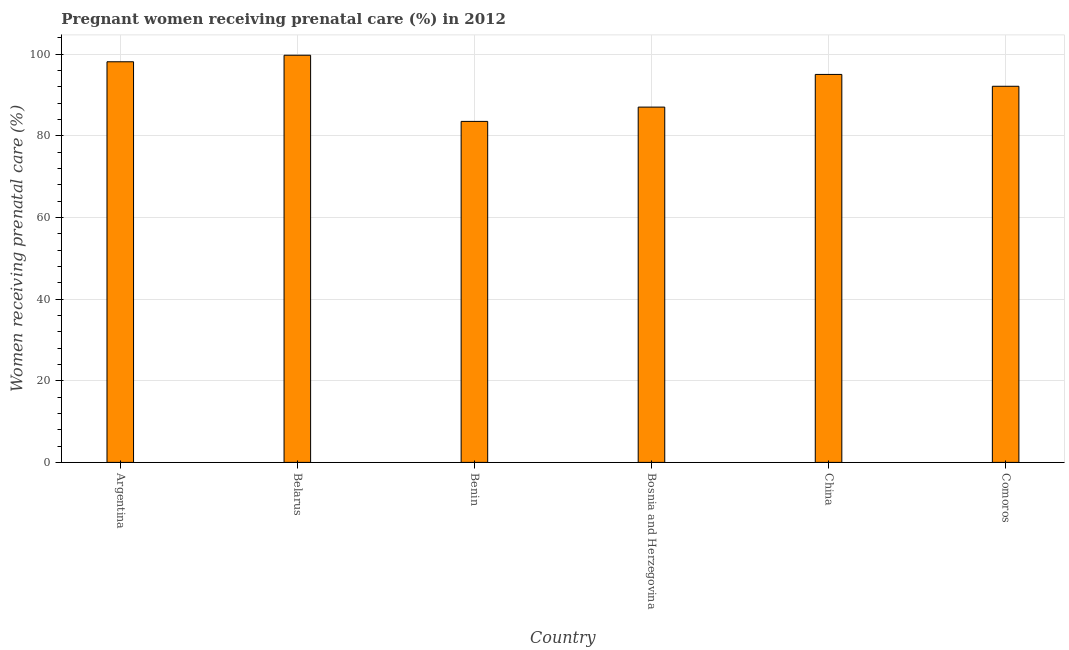What is the title of the graph?
Offer a very short reply. Pregnant women receiving prenatal care (%) in 2012. What is the label or title of the X-axis?
Your response must be concise. Country. What is the label or title of the Y-axis?
Provide a succinct answer. Women receiving prenatal care (%). What is the percentage of pregnant women receiving prenatal care in China?
Make the answer very short. 95. Across all countries, what is the maximum percentage of pregnant women receiving prenatal care?
Offer a very short reply. 99.7. Across all countries, what is the minimum percentage of pregnant women receiving prenatal care?
Your answer should be compact. 83.5. In which country was the percentage of pregnant women receiving prenatal care maximum?
Offer a very short reply. Belarus. In which country was the percentage of pregnant women receiving prenatal care minimum?
Your answer should be compact. Benin. What is the sum of the percentage of pregnant women receiving prenatal care?
Offer a very short reply. 555.4. What is the average percentage of pregnant women receiving prenatal care per country?
Give a very brief answer. 92.57. What is the median percentage of pregnant women receiving prenatal care?
Make the answer very short. 93.55. What is the ratio of the percentage of pregnant women receiving prenatal care in Belarus to that in Bosnia and Herzegovina?
Ensure brevity in your answer.  1.15. Is the percentage of pregnant women receiving prenatal care in Argentina less than that in China?
Provide a short and direct response. No. Is the sum of the percentage of pregnant women receiving prenatal care in Bosnia and Herzegovina and Comoros greater than the maximum percentage of pregnant women receiving prenatal care across all countries?
Give a very brief answer. Yes. What is the difference between the highest and the lowest percentage of pregnant women receiving prenatal care?
Give a very brief answer. 16.2. In how many countries, is the percentage of pregnant women receiving prenatal care greater than the average percentage of pregnant women receiving prenatal care taken over all countries?
Make the answer very short. 3. What is the difference between two consecutive major ticks on the Y-axis?
Offer a very short reply. 20. What is the Women receiving prenatal care (%) of Argentina?
Give a very brief answer. 98.1. What is the Women receiving prenatal care (%) in Belarus?
Make the answer very short. 99.7. What is the Women receiving prenatal care (%) in Benin?
Your answer should be very brief. 83.5. What is the Women receiving prenatal care (%) of Comoros?
Give a very brief answer. 92.1. What is the difference between the Women receiving prenatal care (%) in Argentina and Bosnia and Herzegovina?
Make the answer very short. 11.1. What is the difference between the Women receiving prenatal care (%) in Belarus and Bosnia and Herzegovina?
Offer a very short reply. 12.7. What is the difference between the Women receiving prenatal care (%) in Belarus and China?
Make the answer very short. 4.7. What is the difference between the Women receiving prenatal care (%) in Benin and China?
Offer a very short reply. -11.5. What is the difference between the Women receiving prenatal care (%) in Benin and Comoros?
Provide a short and direct response. -8.6. What is the difference between the Women receiving prenatal care (%) in Bosnia and Herzegovina and China?
Provide a succinct answer. -8. What is the difference between the Women receiving prenatal care (%) in China and Comoros?
Offer a terse response. 2.9. What is the ratio of the Women receiving prenatal care (%) in Argentina to that in Benin?
Ensure brevity in your answer.  1.18. What is the ratio of the Women receiving prenatal care (%) in Argentina to that in Bosnia and Herzegovina?
Keep it short and to the point. 1.13. What is the ratio of the Women receiving prenatal care (%) in Argentina to that in China?
Offer a terse response. 1.03. What is the ratio of the Women receiving prenatal care (%) in Argentina to that in Comoros?
Give a very brief answer. 1.06. What is the ratio of the Women receiving prenatal care (%) in Belarus to that in Benin?
Provide a succinct answer. 1.19. What is the ratio of the Women receiving prenatal care (%) in Belarus to that in Bosnia and Herzegovina?
Your answer should be compact. 1.15. What is the ratio of the Women receiving prenatal care (%) in Belarus to that in China?
Provide a succinct answer. 1.05. What is the ratio of the Women receiving prenatal care (%) in Belarus to that in Comoros?
Make the answer very short. 1.08. What is the ratio of the Women receiving prenatal care (%) in Benin to that in China?
Keep it short and to the point. 0.88. What is the ratio of the Women receiving prenatal care (%) in Benin to that in Comoros?
Give a very brief answer. 0.91. What is the ratio of the Women receiving prenatal care (%) in Bosnia and Herzegovina to that in China?
Provide a succinct answer. 0.92. What is the ratio of the Women receiving prenatal care (%) in Bosnia and Herzegovina to that in Comoros?
Provide a succinct answer. 0.94. What is the ratio of the Women receiving prenatal care (%) in China to that in Comoros?
Your answer should be very brief. 1.03. 